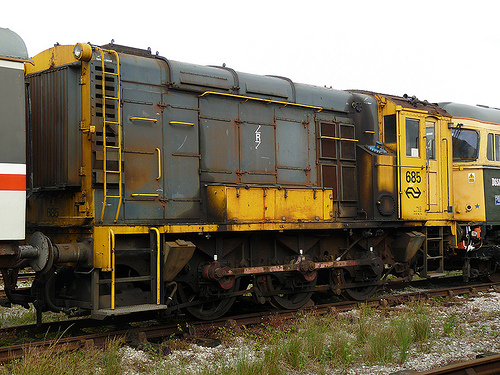Is there any vegetation visible in the image? Yes, there is some grass and small plants growing along the railway tracks in the image. Describe the surroundings of the train car in detail. The surroundings of the train car include railway tracks with some grass and small plants growing alongside them. The ground appears to be gravel, and there are other vehicles visible adjacent to the train car. The atmosphere seems industrial and functional, typical of a railway environment. If the image were part of a story, what kind of story would it be? In a story, this image could represent a critical moment in a historical or adventure narrative. The train car might be part of a forgotten railway station where something significant happened years ago, or it could serve as a backdrop for a thrilling train heist or espionage tale. Alternatively, it could be a setting for a story about the lives of railway workers and the challenges they face in maintaining old machinery and infrastructure. 